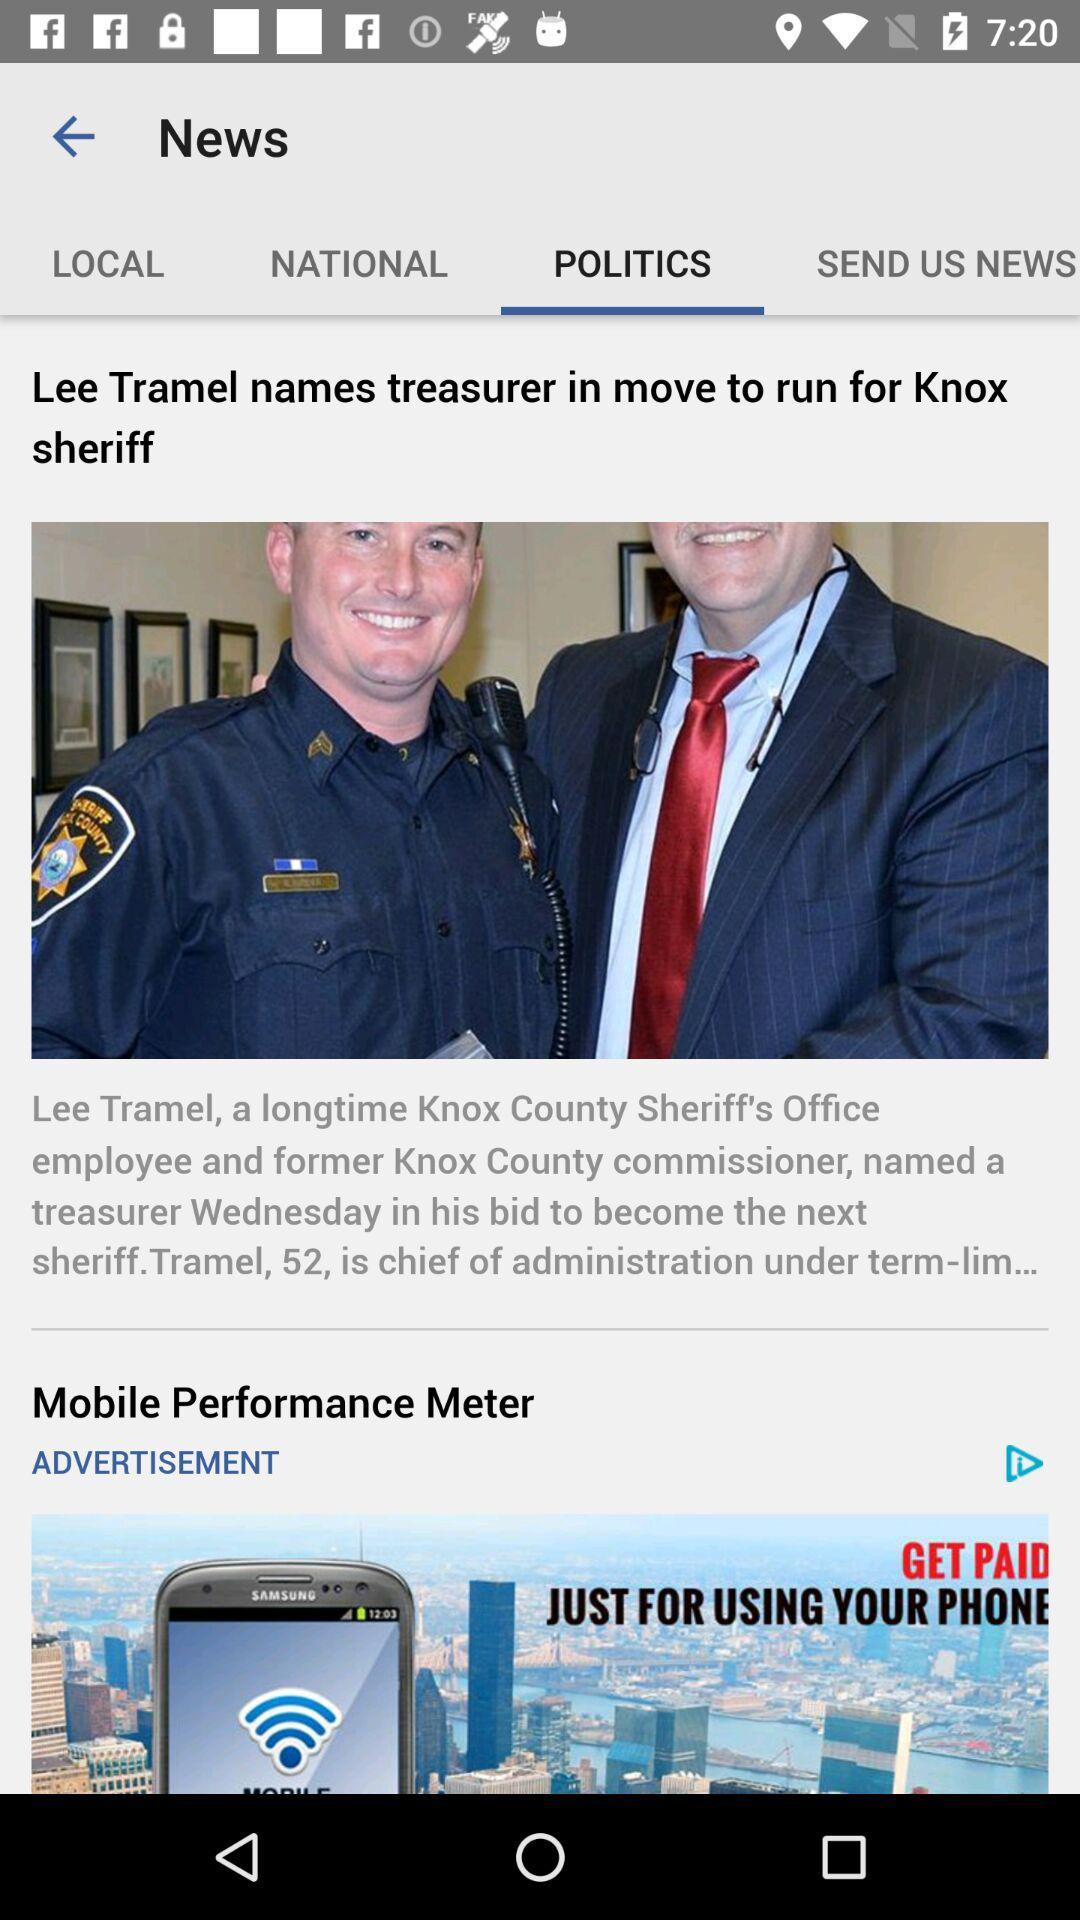Which tab is selected? The selected tab is "POLITICS". 